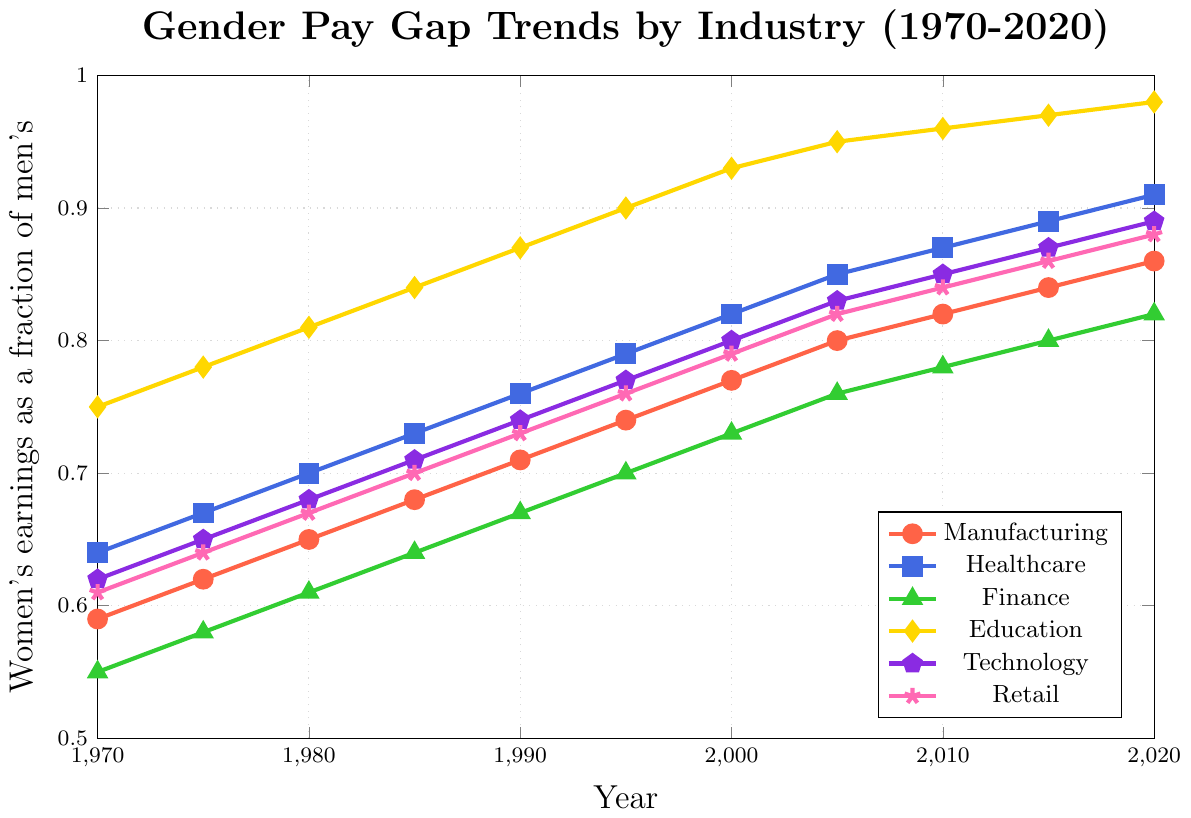What industry showed the smallest gender pay gap in 1970? By examining the 1970 data points for each industry, Education has the highest women's earnings as a fraction of men's, which indicates the smallest gender pay gap.
Answer: Education Which sector made the greatest improvement from 1970 to 2020 in terms of narrowing the gender pay gap? Calculate the difference in the women's earnings fraction from 1970 to 2020 for each sector. The difference is greatest for Retail, indicating the most significant improvement.
Answer: Retail As of 2020, do women earn closer to men's earnings in Healthcare or Technology? Compare the 2020 values for Healthcare (0.91) and Technology (0.89). Women's earnings as a fraction of men's are higher in Healthcare.
Answer: Healthcare Between 1980 and 2020, which industry showed the least improvement in closing the gender pay gap? Calculate the difference between the 1980 and 2020 values for each industry. The smallest improvement is observed in Education (0.98 - 0.81 = 0.17).
Answer: Education By how many percentage points did the gender pay gap decrease in Manufacturing from 1970 to 1990? Subtract the 1970 value from the 1990 value for Manufacturing: (0.71 - 0.59) = 0.12 or 12 percentage points.
Answer: 12 What is the average fraction of women's earnings to men's in Finance over the entire period (1970-2020)? Sum the fractions for Finance across the years (0.55 + 0.58 + 0.61 + 0.64 + 0.67 + 0.70 + 0.73 + 0.76 + 0.78 + 0.80 + 0.82) = 7.64. There are 11 data points, so 7.64 / 11 ≈ 0.69.
Answer: 0.69 In which year did Retail achieve an earnings fraction of 0.82? Look at the data points for Retail and find where the fraction is 0.82, which is in 2005.
Answer: 2005 Which two industries were closest in terms of women's earnings as a fraction of men's in 2020? Compare the 2020 fractions for all pairs. The closest values are Healthcare (0.91) and Technology (0.89).
Answer: Healthcare and Technology 